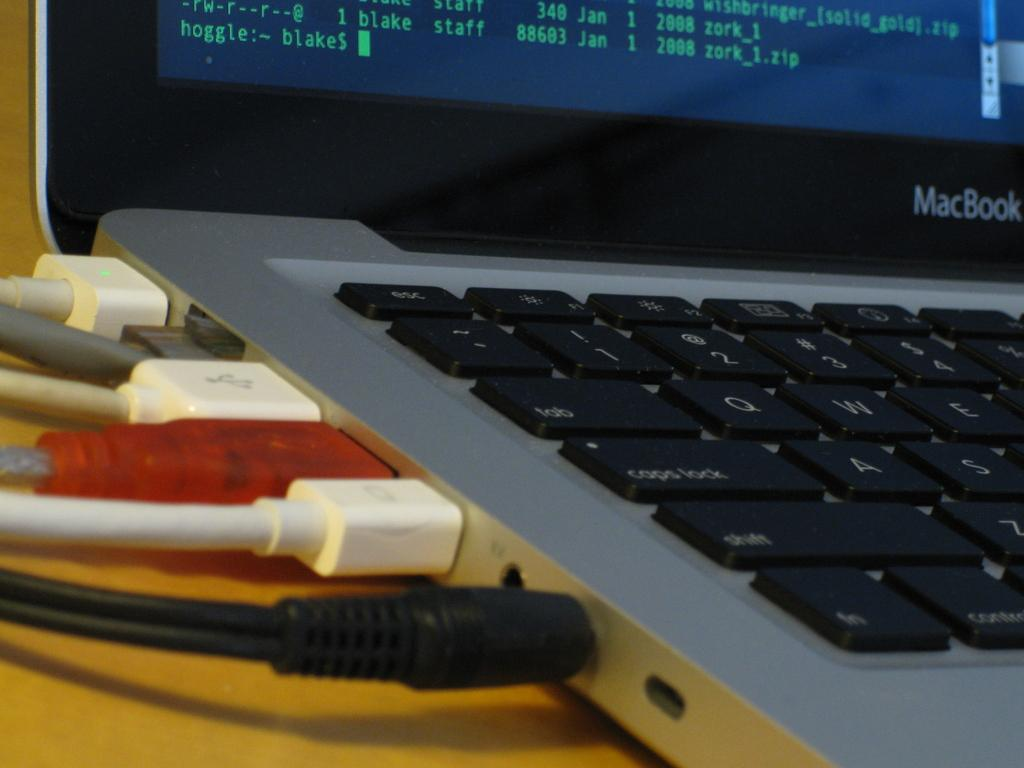Provide a one-sentence caption for the provided image. A Macbook shows all the cords attached to it. 